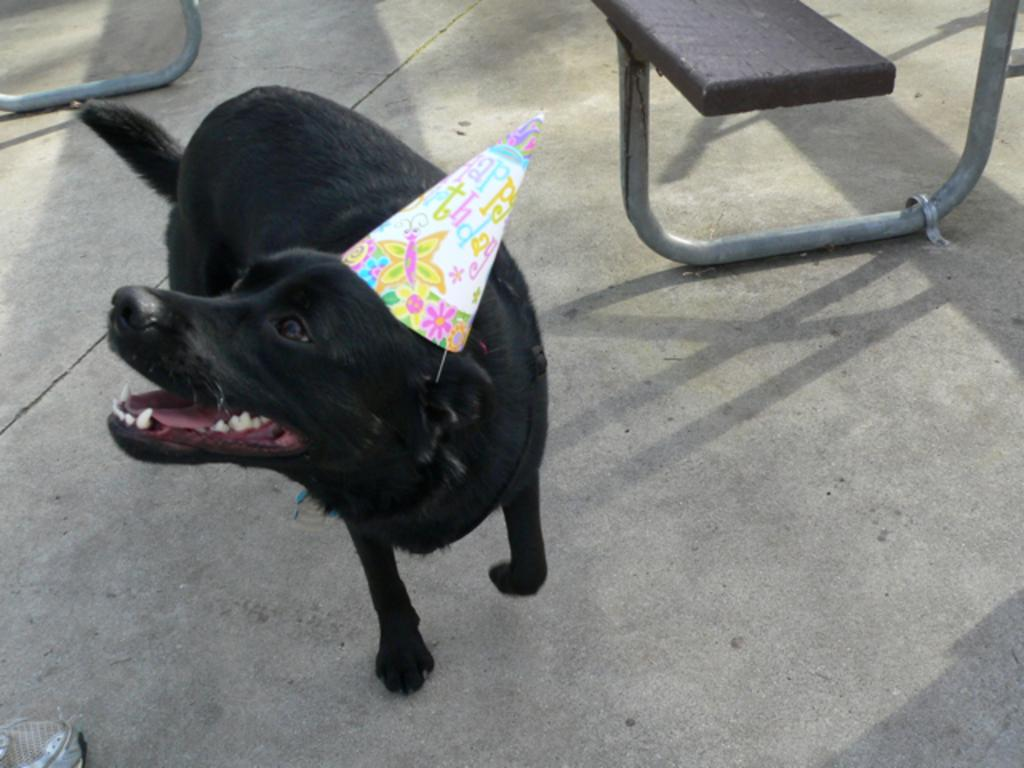What type of animal is in the image? There is a dog in the image. What is the dog wearing? The dog is wearing a cap. Where is the dog located in the image? The dog is on the floor. What can be seen in the background of the image? There is a bench in the background of the image. How many geese are sitting on the dog's head in the image? There are no geese present in the image, and therefore none are sitting on the dog's head. What type of tent is visible in the background of the image? There is no tent present in the image; only a bench can be seen in the background. 